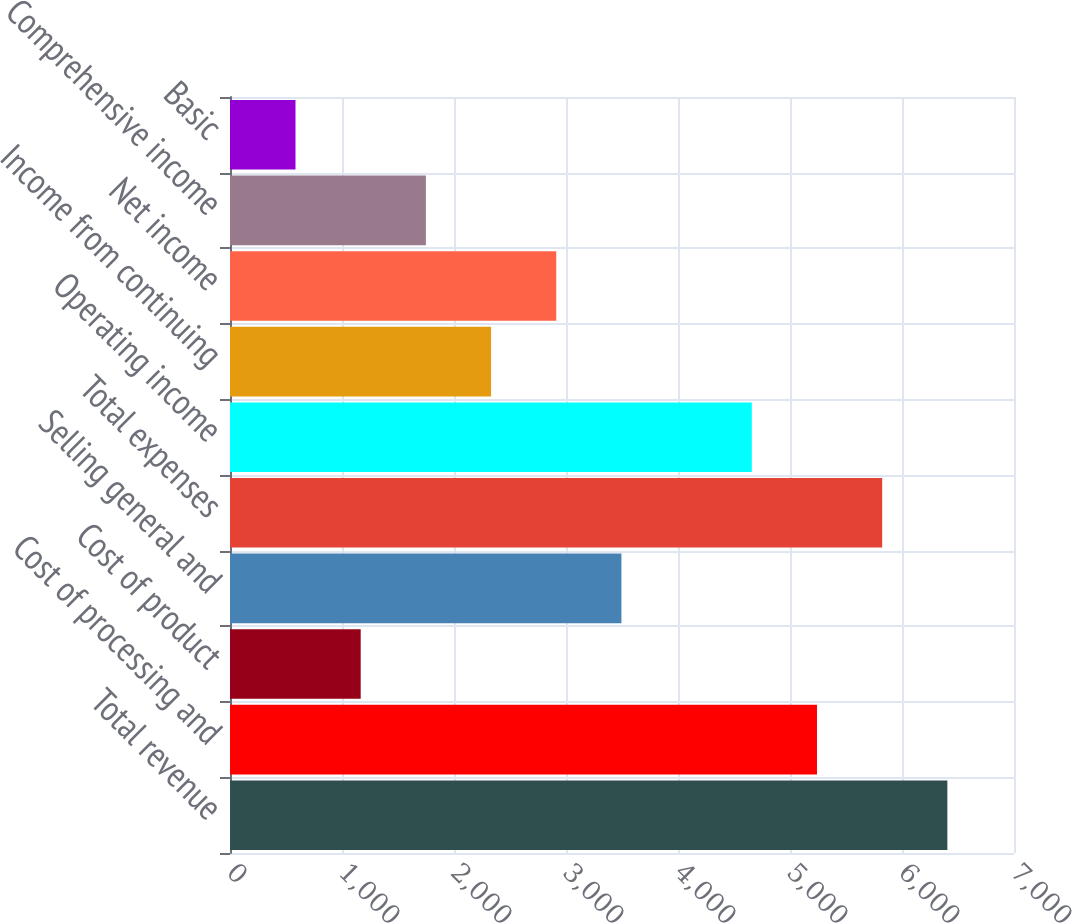<chart> <loc_0><loc_0><loc_500><loc_500><bar_chart><fcel>Total revenue<fcel>Cost of processing and<fcel>Cost of product<fcel>Selling general and<fcel>Total expenses<fcel>Operating income<fcel>Income from continuing<fcel>Net income<fcel>Comprehensive income<fcel>Basic<nl><fcel>6404.98<fcel>5240.96<fcel>1166.89<fcel>3494.93<fcel>5822.97<fcel>4658.95<fcel>2330.91<fcel>2912.92<fcel>1748.9<fcel>584.88<nl></chart> 